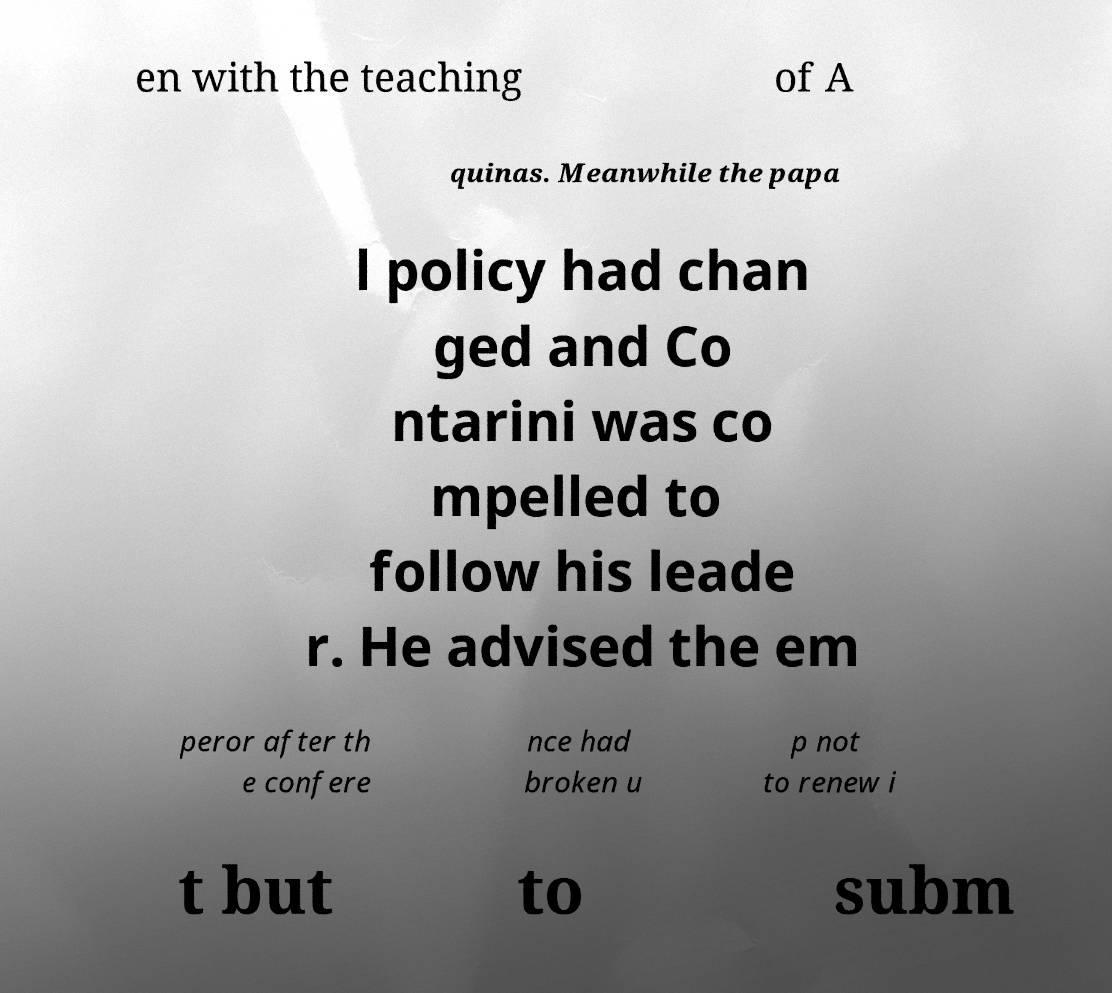For documentation purposes, I need the text within this image transcribed. Could you provide that? en with the teaching of A quinas. Meanwhile the papa l policy had chan ged and Co ntarini was co mpelled to follow his leade r. He advised the em peror after th e confere nce had broken u p not to renew i t but to subm 